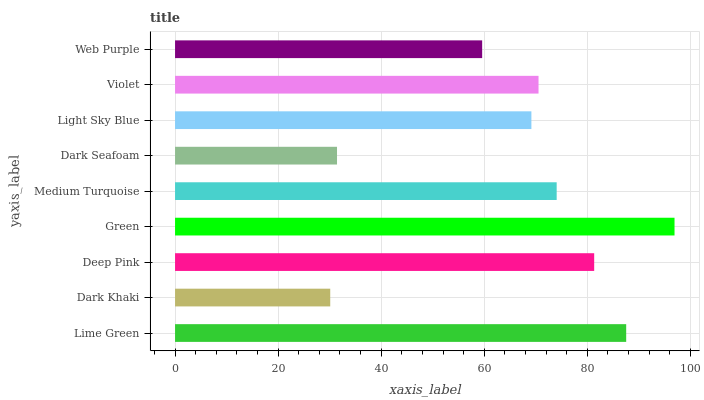Is Dark Khaki the minimum?
Answer yes or no. Yes. Is Green the maximum?
Answer yes or no. Yes. Is Deep Pink the minimum?
Answer yes or no. No. Is Deep Pink the maximum?
Answer yes or no. No. Is Deep Pink greater than Dark Khaki?
Answer yes or no. Yes. Is Dark Khaki less than Deep Pink?
Answer yes or no. Yes. Is Dark Khaki greater than Deep Pink?
Answer yes or no. No. Is Deep Pink less than Dark Khaki?
Answer yes or no. No. Is Violet the high median?
Answer yes or no. Yes. Is Violet the low median?
Answer yes or no. Yes. Is Medium Turquoise the high median?
Answer yes or no. No. Is Dark Seafoam the low median?
Answer yes or no. No. 